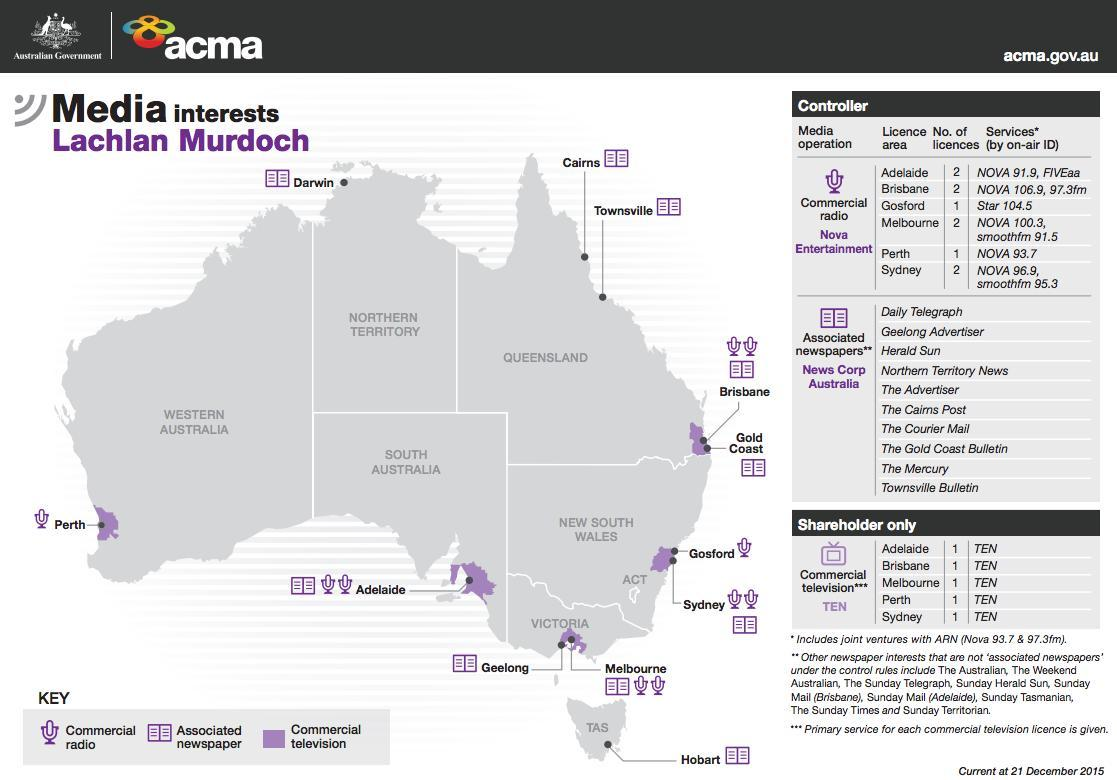Which media are interested in Perth?
Answer the question with a short phrase. Commercial radio, Commerical television How many newspapers are available in Australia? 10 Which media are interested in Gold Coast? Associated newspaper, Commercial television Which media are interested in Hobart? Associated newspaper How many media are interested in Brisbane? 3 Commercial television is interested in how many areas of Australia? 5 How many areas have the number of licenses as 2? 4 Which media are interested in Cairns? Associated newspaper How many media are interested in Perth? 2 